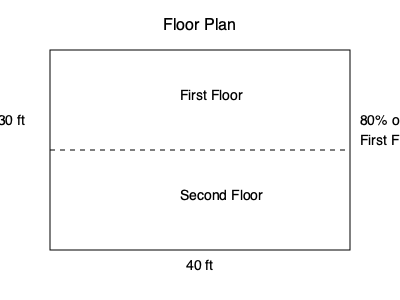As you review the floor plans for your dream house with the government official, you notice that the first floor measures 40 ft by 30 ft, while the second floor occupies 80% of the first floor's area. What is the total square footage of your new home? To calculate the total square footage of the house, we need to follow these steps:

1. Calculate the area of the first floor:
   $A_1 = 40 \text{ ft} \times 30 \text{ ft} = 1200 \text{ sq ft}$

2. Calculate the area of the second floor:
   The second floor is 80% of the first floor's area.
   $A_2 = 80\% \times 1200 \text{ sq ft} = 0.8 \times 1200 \text{ sq ft} = 960 \text{ sq ft}$

3. Sum up the areas of both floors to get the total square footage:
   $A_{\text{total}} = A_1 + A_2 = 1200 \text{ sq ft} + 960 \text{ sq ft} = 2160 \text{ sq ft}$

Therefore, the total square footage of your new home is 2160 square feet.
Answer: 2160 sq ft 